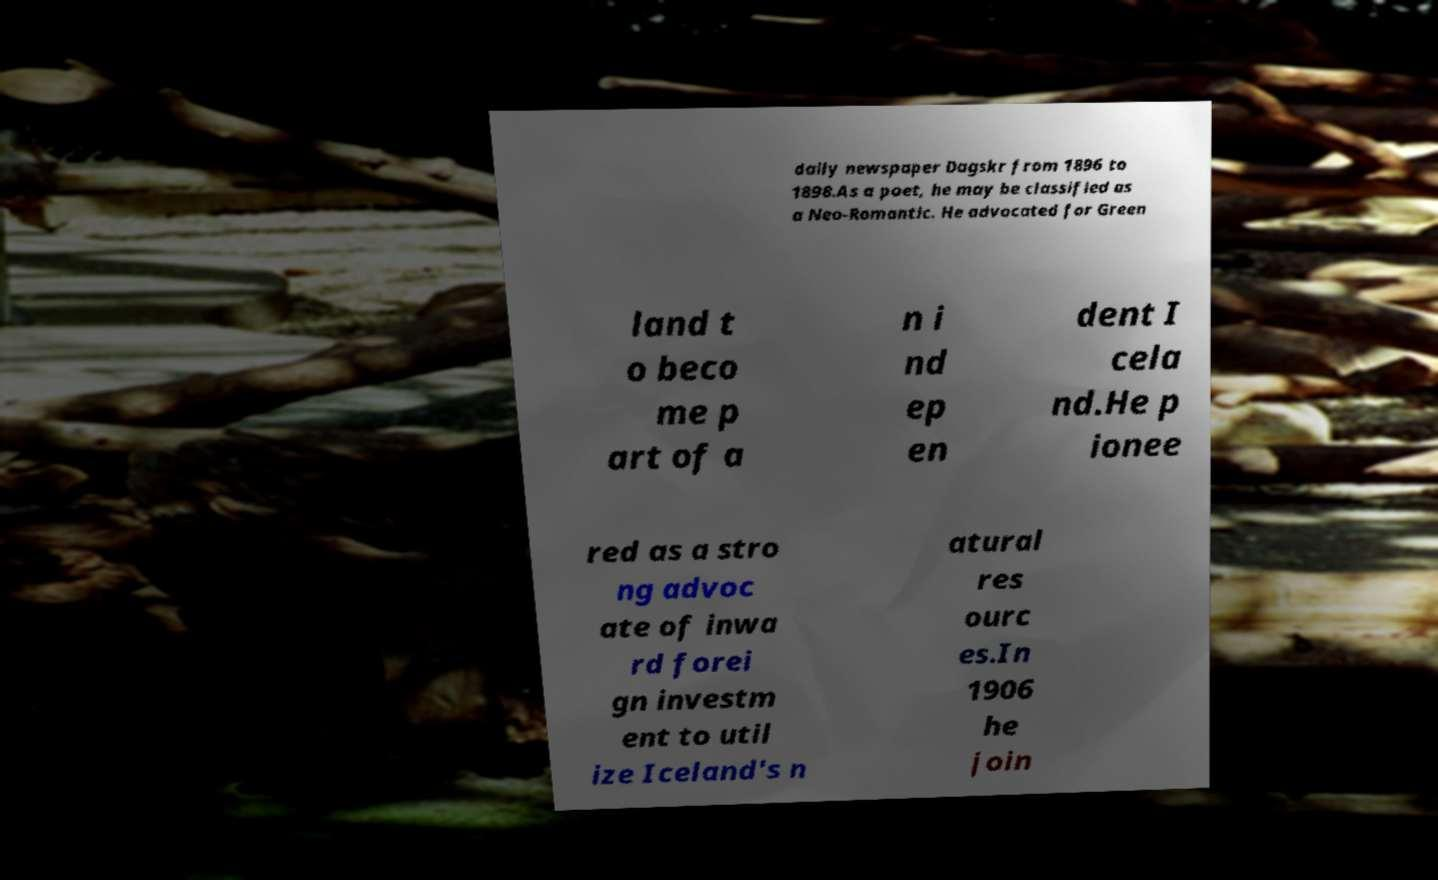Please read and relay the text visible in this image. What does it say? daily newspaper Dagskr from 1896 to 1898.As a poet, he may be classified as a Neo-Romantic. He advocated for Green land t o beco me p art of a n i nd ep en dent I cela nd.He p ionee red as a stro ng advoc ate of inwa rd forei gn investm ent to util ize Iceland's n atural res ourc es.In 1906 he join 